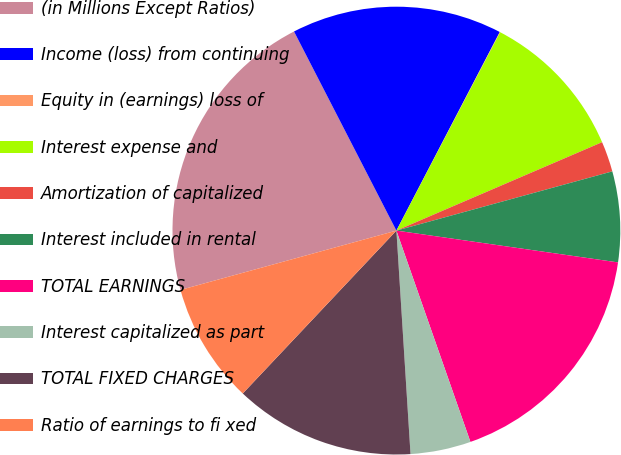Convert chart to OTSL. <chart><loc_0><loc_0><loc_500><loc_500><pie_chart><fcel>(in Millions Except Ratios)<fcel>Income (loss) from continuing<fcel>Equity in (earnings) loss of<fcel>Interest expense and<fcel>Amortization of capitalized<fcel>Interest included in rental<fcel>TOTAL EARNINGS<fcel>Interest capitalized as part<fcel>TOTAL FIXED CHARGES<fcel>Ratio of earnings to fi xed<nl><fcel>21.71%<fcel>15.2%<fcel>0.03%<fcel>10.87%<fcel>2.2%<fcel>6.53%<fcel>17.37%<fcel>4.36%<fcel>13.04%<fcel>8.7%<nl></chart> 